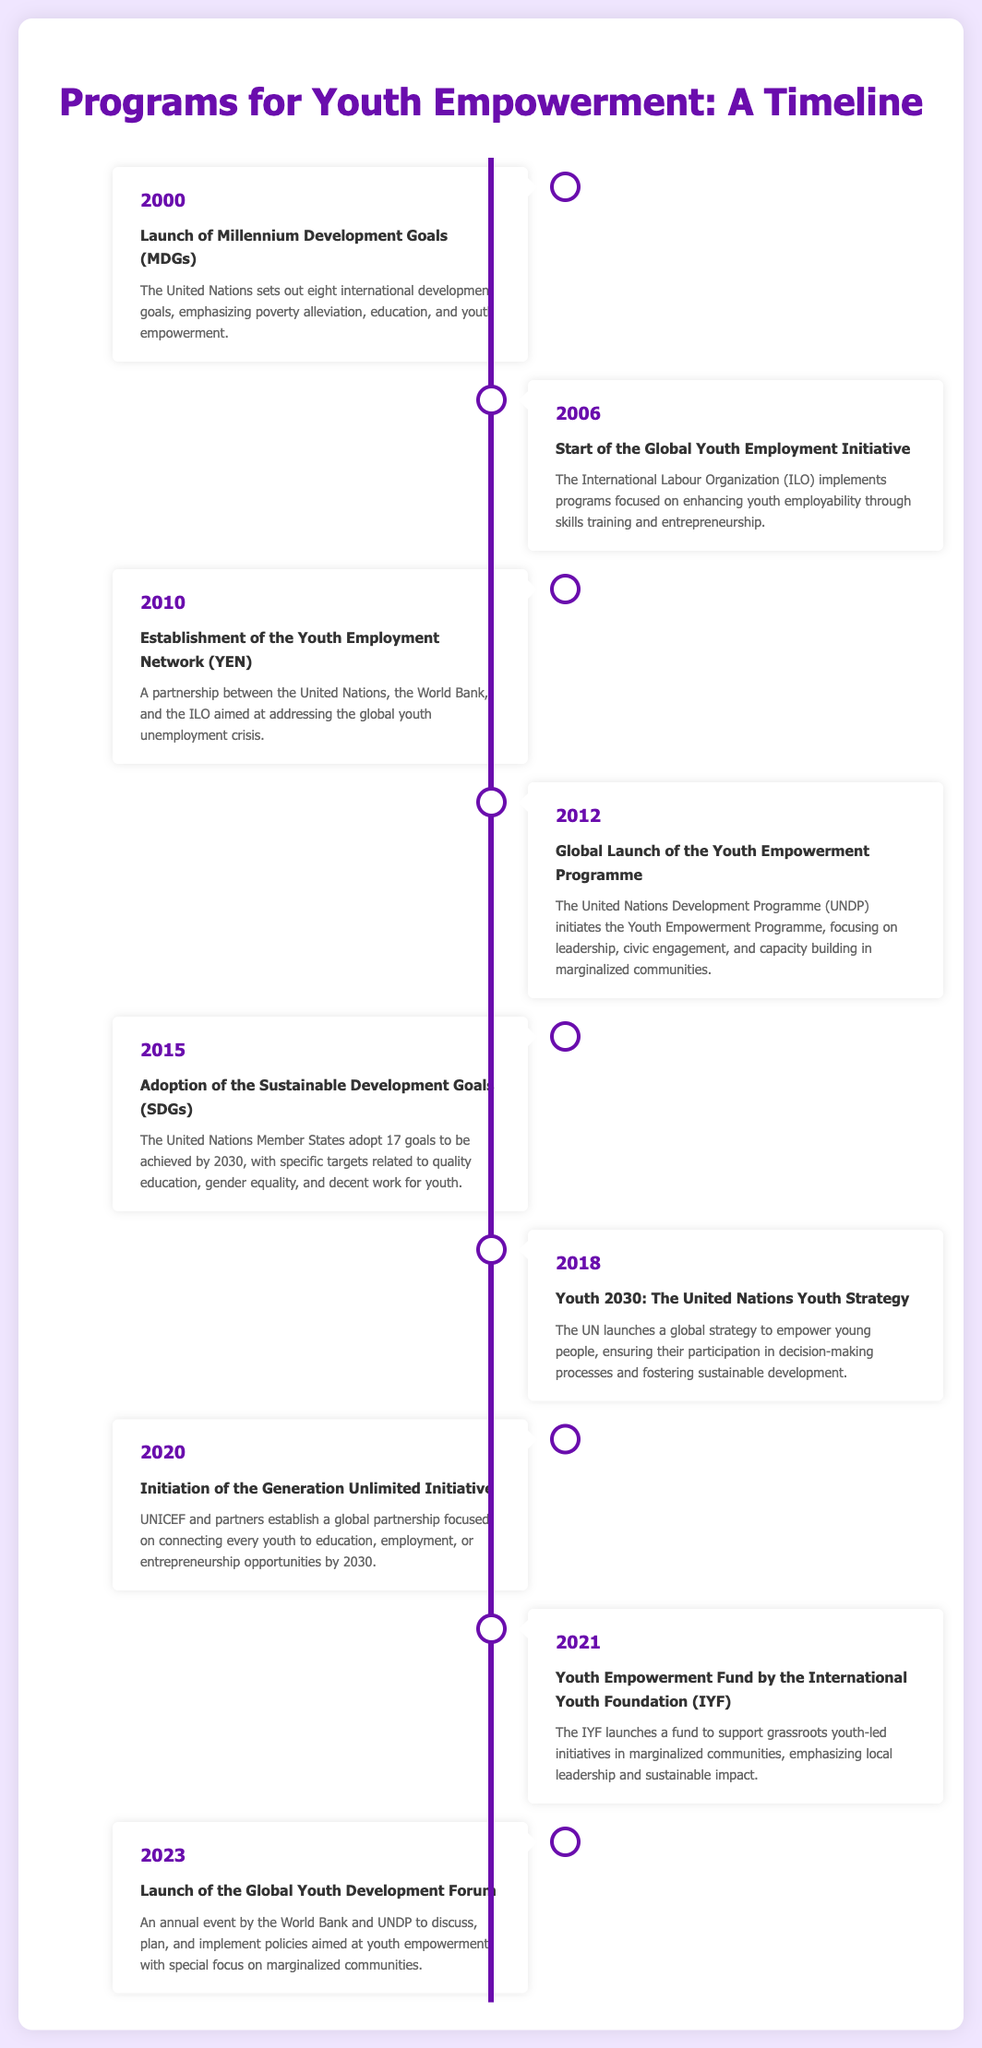What year did the Millennium Development Goals launch? The document states that the Millennium Development Goals were launched in 2000.
Answer: 2000 Which organization initiated the Youth Empowerment Programme in 2012? The Youth Empowerment Programme was initiated by the United Nations Development Programme (UNDP).
Answer: UNDP How many Sustainable Development Goals were adopted in 2015? The document mentions that 17 Sustainable Development Goals were adopted.
Answer: 17 What is the main focus of the Generation Unlimited Initiative launched in 2020? The initiative aims to connect every youth to education, employment, or entrepreneurship opportunities by 2030.
Answer: Education, employment, or entrepreneurship What was established in 2010 as part of a partnership involving the UN, World Bank, and ILO? The Youth Employment Network (YEN) was established to address youth unemployment.
Answer: Youth Employment Network (YEN) Which year saw the launch of the Youth Empowerment Fund by the International Youth Foundation? According to the timeline, the Youth Empowerment Fund was launched in 2021.
Answer: 2021 What was a key objective of the UN's Youth 2030 strategy launched in 2018? The strategy aimed at ensuring youth participation in decision-making processes.
Answer: Youth participation What type of event is the Global Youth Development Forum launched in 2023? It is an annual event aimed at discussing and planning youth empowerment policies.
Answer: Annual event What organization implements the Global Youth Employment Initiative that started in 2006? The International Labour Organization (ILO) is responsible for implementing this initiative.
Answer: International Labour Organization (ILO) 